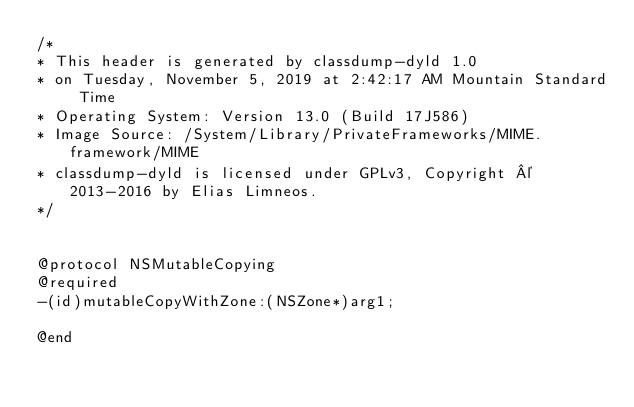<code> <loc_0><loc_0><loc_500><loc_500><_C_>/*
* This header is generated by classdump-dyld 1.0
* on Tuesday, November 5, 2019 at 2:42:17 AM Mountain Standard Time
* Operating System: Version 13.0 (Build 17J586)
* Image Source: /System/Library/PrivateFrameworks/MIME.framework/MIME
* classdump-dyld is licensed under GPLv3, Copyright © 2013-2016 by Elias Limneos.
*/


@protocol NSMutableCopying
@required
-(id)mutableCopyWithZone:(NSZone*)arg1;

@end

</code> 